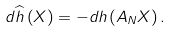<formula> <loc_0><loc_0><loc_500><loc_500>d \widehat { h } \left ( X \right ) = - d h \left ( A _ { N } X \right ) .</formula> 